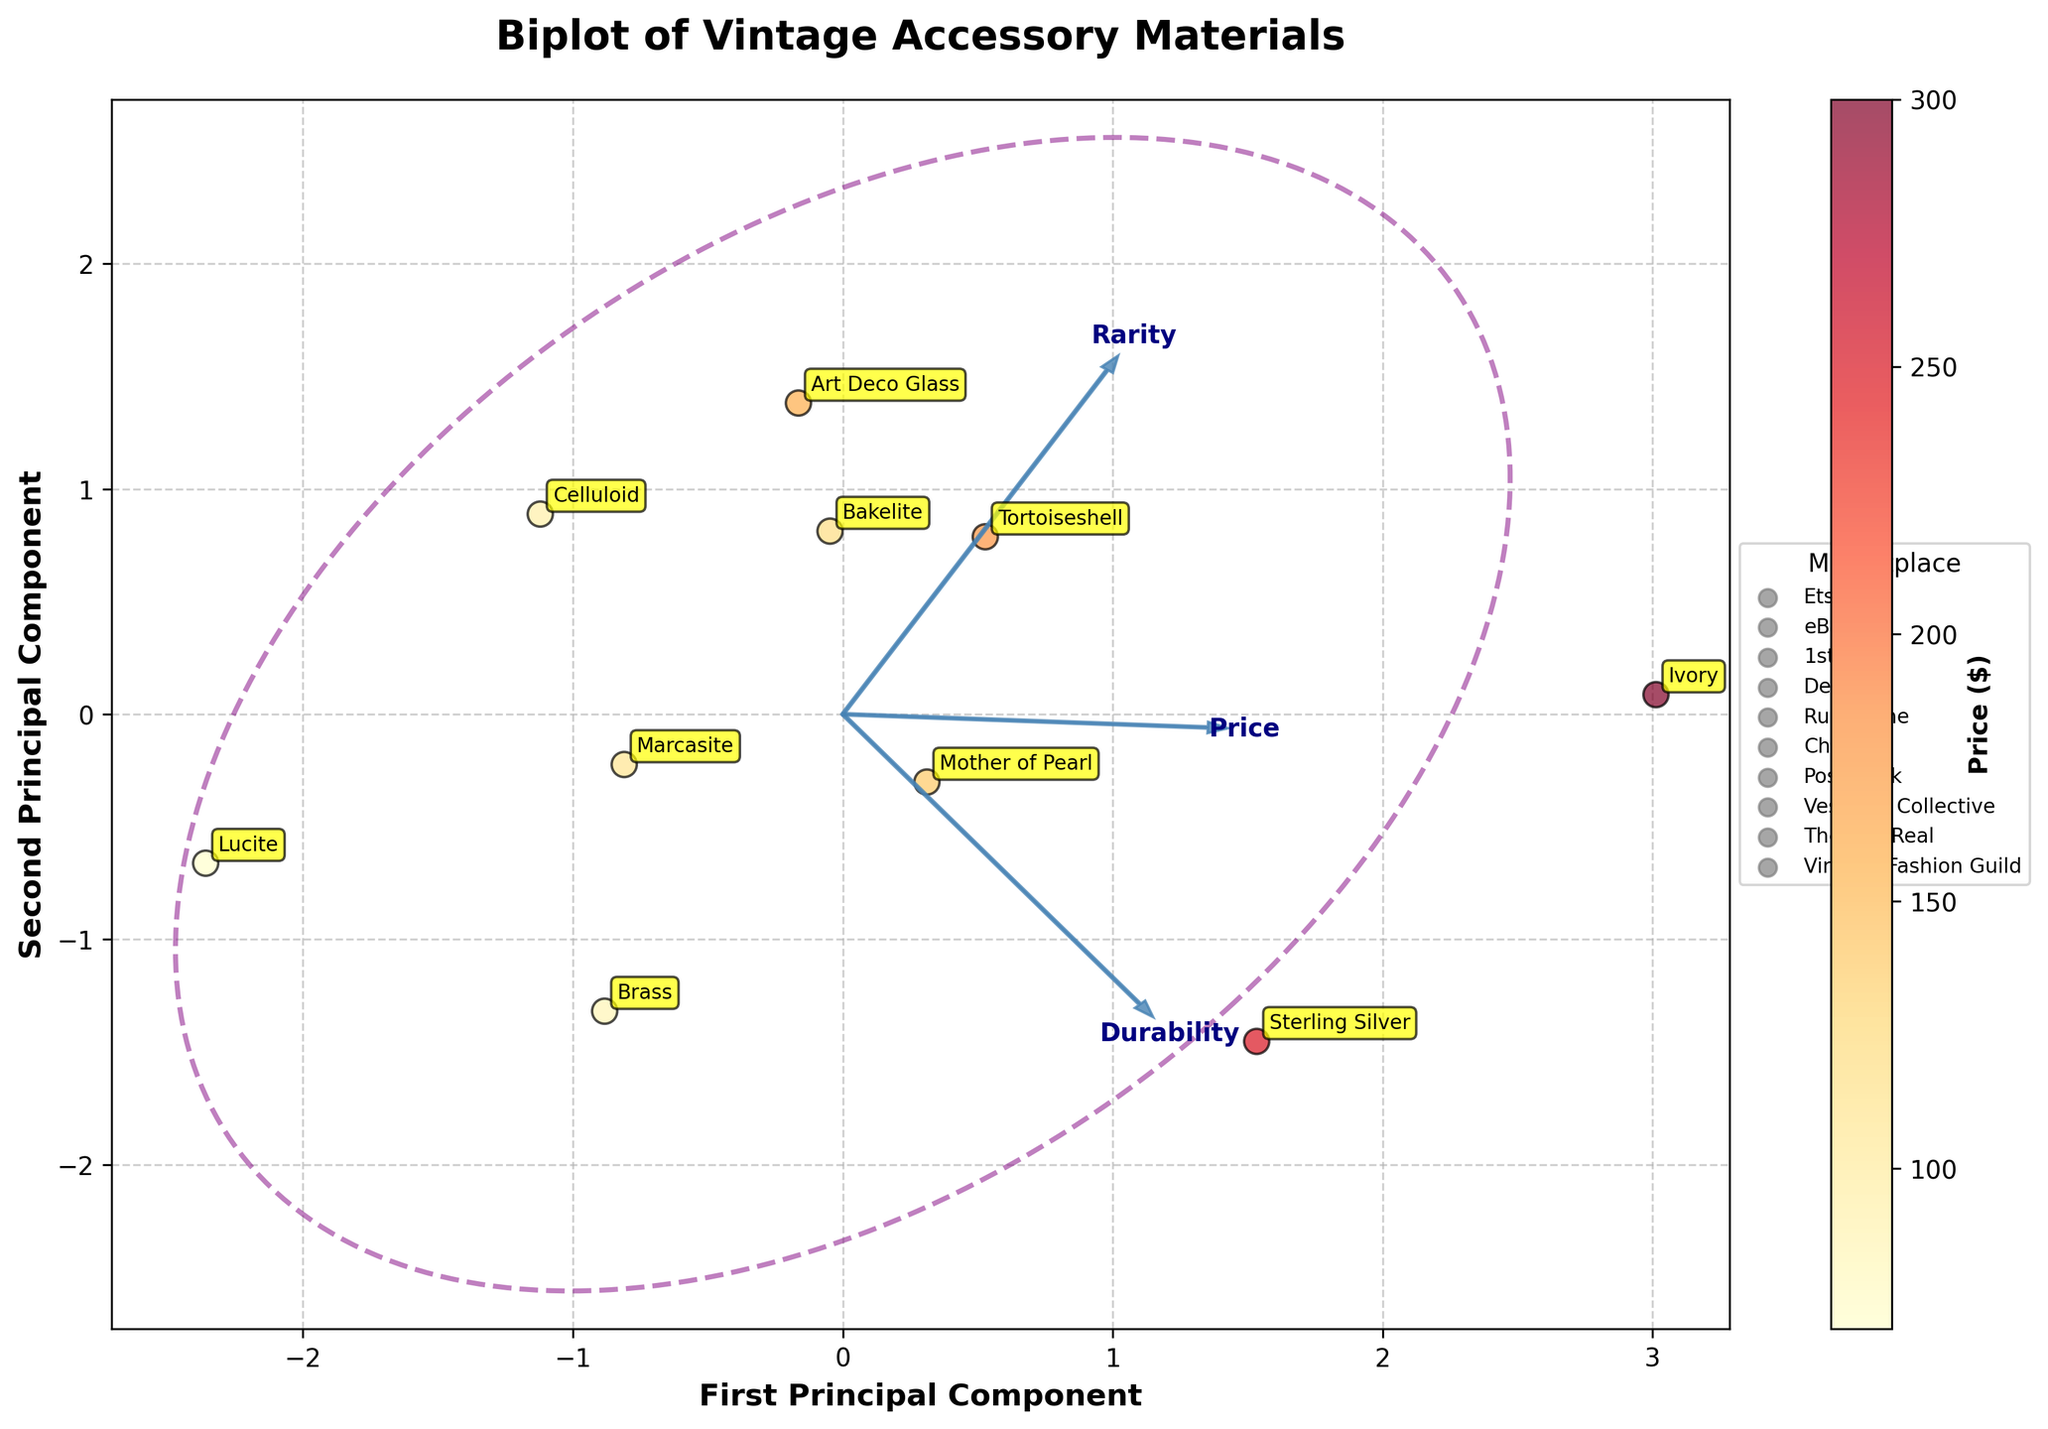Which material is associated with the highest price? Look at the color gradient that represents the price, we can see the dark red spot which indicates the highest price. The material label next to this point is Ivory.
Answer: Ivory Which feature vector has the highest influence on the first principal component? The first principal component is represented by the horizontal axis. The feature vector arrow that stretches the furthest along this axis shows the strongest influence, which is the 'Price' vector.
Answer: Price Which marketplace has the most presence in the plot? To determine marketplace presence, count the number of labeled points for each marketplace. Etsy has the most points visible.
Answer: Etsy Between Bakelite and Celluloid, which has a higher price? Refer to the colors of the points labeled Bakelite and Celluloid. Bakelite is darker red compared to Celluloid which suggests a higher price.
Answer: Bakelite How many materials fall within the confidence ellipse? Count the number of labeled points that are within or touch the ellipse boundary. In this case, 7 points are within the ellipse.
Answer: 7 Which material scores highest in durability? Observe the direction and length of the 'Durability' feature vector and identify the material nearest to where this vector projects farthest. Sterling Silver and Ivory are closer to the high influence end of this vector.
Answer: Sterling Silver and Ivory What is the range of prices represented in this plot? The color gradient serves as a reference to the price values. The lightest shade corresponds to Lucite at $70 and the darkest shade corresponds to Ivory at $300.
Answer: $70 - $300 Which material is positioned closest to the origin in the biplot? Identify the material label that is closest to the center of the plot (0,0). Lucite is the material positioned closest to the origin.
Answer: Lucite How are the 'Rarity' values represented in the biplot? The 'Rarity' values are demonstrated by the direction and magnitude of the Rarity feature vector. Materials positioned along this vector are indicative of higher or lower Rarity.
Answer: By the 'Rarity' feature vector In terms of rarity, which marketplace offers the rarest accessories? Look at the gradient along the 'Rarity' vector and the marketplaces associated with materials in this high Rarity range. Ruby Lane, representing Ivory, is at the higher end of the 'Rarity' vector.
Answer: Ruby Lane 